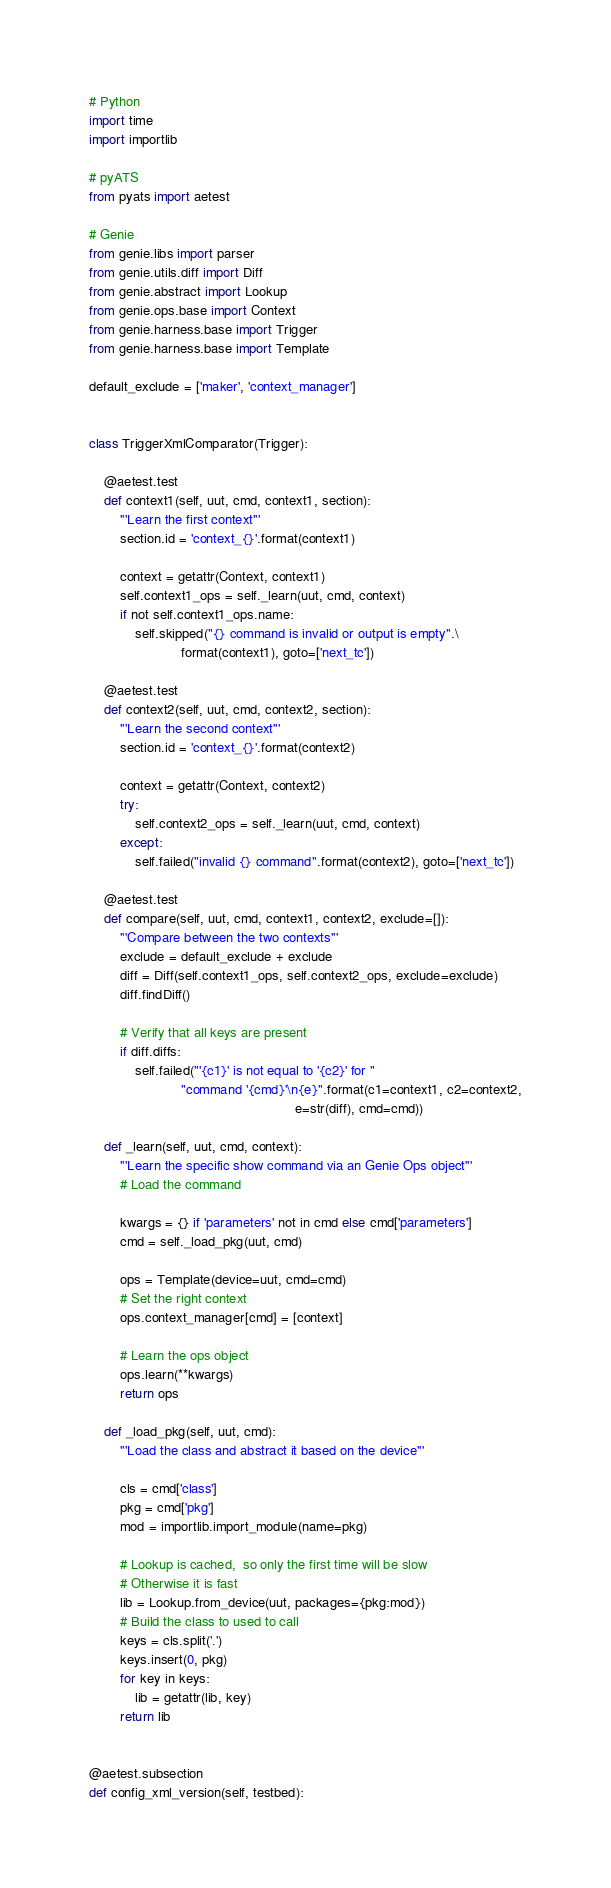<code> <loc_0><loc_0><loc_500><loc_500><_Python_>
# Python
import time
import importlib

# pyATS
from pyats import aetest

# Genie
from genie.libs import parser
from genie.utils.diff import Diff
from genie.abstract import Lookup
from genie.ops.base import Context
from genie.harness.base import Trigger
from genie.harness.base import Template

default_exclude = ['maker', 'context_manager']


class TriggerXmlComparator(Trigger):

    @aetest.test
    def context1(self, uut, cmd, context1, section):
        '''Learn the first context'''
        section.id = 'context_{}'.format(context1)

        context = getattr(Context, context1)
        self.context1_ops = self._learn(uut, cmd, context)
        if not self.context1_ops.name:
            self.skipped("{} command is invalid or output is empty".\
                        format(context1), goto=['next_tc'])

    @aetest.test
    def context2(self, uut, cmd, context2, section):
        '''Learn the second context'''
        section.id = 'context_{}'.format(context2)

        context = getattr(Context, context2)
        try:
            self.context2_ops = self._learn(uut, cmd, context)
        except:
            self.failed("invalid {} command".format(context2), goto=['next_tc'])

    @aetest.test
    def compare(self, uut, cmd, context1, context2, exclude=[]):
        '''Compare between the two contexts'''
        exclude = default_exclude + exclude
        diff = Diff(self.context1_ops, self.context2_ops, exclude=exclude)
        diff.findDiff()

        # Verify that all keys are present
        if diff.diffs:
            self.failed("'{c1}' is not equal to '{c2}' for "
                        "command '{cmd}'\n{e}".format(c1=context1, c2=context2,
                                                      e=str(diff), cmd=cmd))

    def _learn(self, uut, cmd, context):
        '''Learn the specific show command via an Genie Ops object'''
        # Load the command
        
        kwargs = {} if 'parameters' not in cmd else cmd['parameters']
        cmd = self._load_pkg(uut, cmd)

        ops = Template(device=uut, cmd=cmd)
        # Set the right context
        ops.context_manager[cmd] = [context]

        # Learn the ops object
        ops.learn(**kwargs)
        return ops

    def _load_pkg(self, uut, cmd):
        '''Load the class and abstract it based on the device'''

        cls = cmd['class']
        pkg = cmd['pkg']
        mod = importlib.import_module(name=pkg)

        # Lookup is cached,  so only the first time will be slow
        # Otherwise it is fast
        lib = Lookup.from_device(uut, packages={pkg:mod})
        # Build the class to used to call
        keys = cls.split('.')
        keys.insert(0, pkg)
        for key in keys:
            lib = getattr(lib, key) 
        return lib


@aetest.subsection
def config_xml_version(self, testbed):</code> 